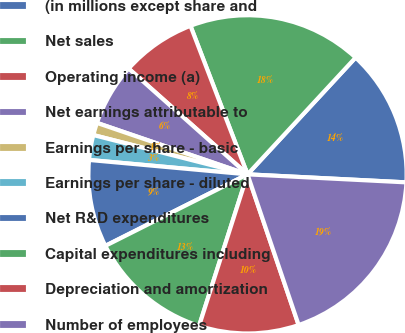Convert chart. <chart><loc_0><loc_0><loc_500><loc_500><pie_chart><fcel>(in millions except share and<fcel>Net sales<fcel>Operating income (a)<fcel>Net earnings attributable to<fcel>Earnings per share - basic<fcel>Earnings per share - diluted<fcel>Net R&D expenditures<fcel>Capital expenditures including<fcel>Depreciation and amortization<fcel>Number of employees<nl><fcel>13.92%<fcel>17.72%<fcel>7.59%<fcel>6.33%<fcel>1.27%<fcel>2.53%<fcel>8.86%<fcel>12.66%<fcel>10.13%<fcel>18.99%<nl></chart> 